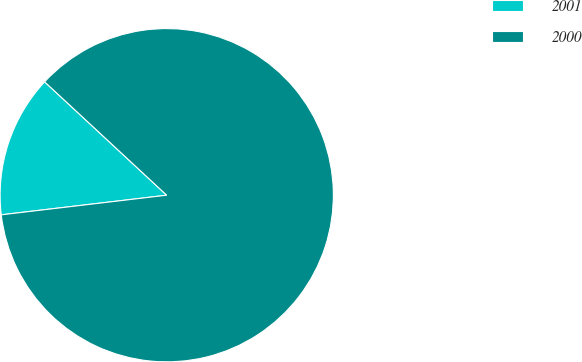<chart> <loc_0><loc_0><loc_500><loc_500><pie_chart><fcel>2001<fcel>2000<nl><fcel>13.79%<fcel>86.21%<nl></chart> 